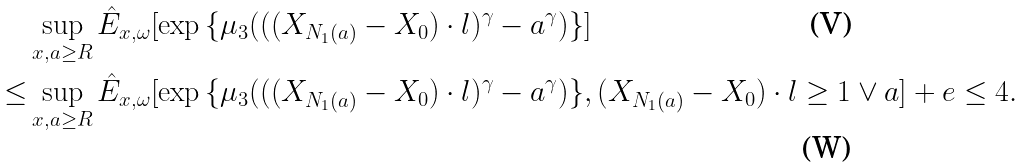Convert formula to latex. <formula><loc_0><loc_0><loc_500><loc_500>& \sup _ { x , a \geq R } { \hat { E } _ { x , \omega } } [ \exp { \{ \mu _ { 3 } ( ( ( X _ { N _ { 1 } ( a ) } - X _ { 0 } ) \cdot l ) ^ { \gamma } - a ^ { \gamma } ) \} } ] \\ \leq & \sup _ { x , a \geq R } { \hat { E } _ { x , \omega } } [ \exp { \{ \mu _ { 3 } ( ( ( X _ { N _ { 1 } ( a ) } - X _ { 0 } ) \cdot l ) ^ { \gamma } - a ^ { \gamma } ) \} } , ( X _ { N _ { 1 } ( a ) } - X _ { 0 } ) \cdot l \geq 1 \vee a ] + e \leq 4 .</formula> 